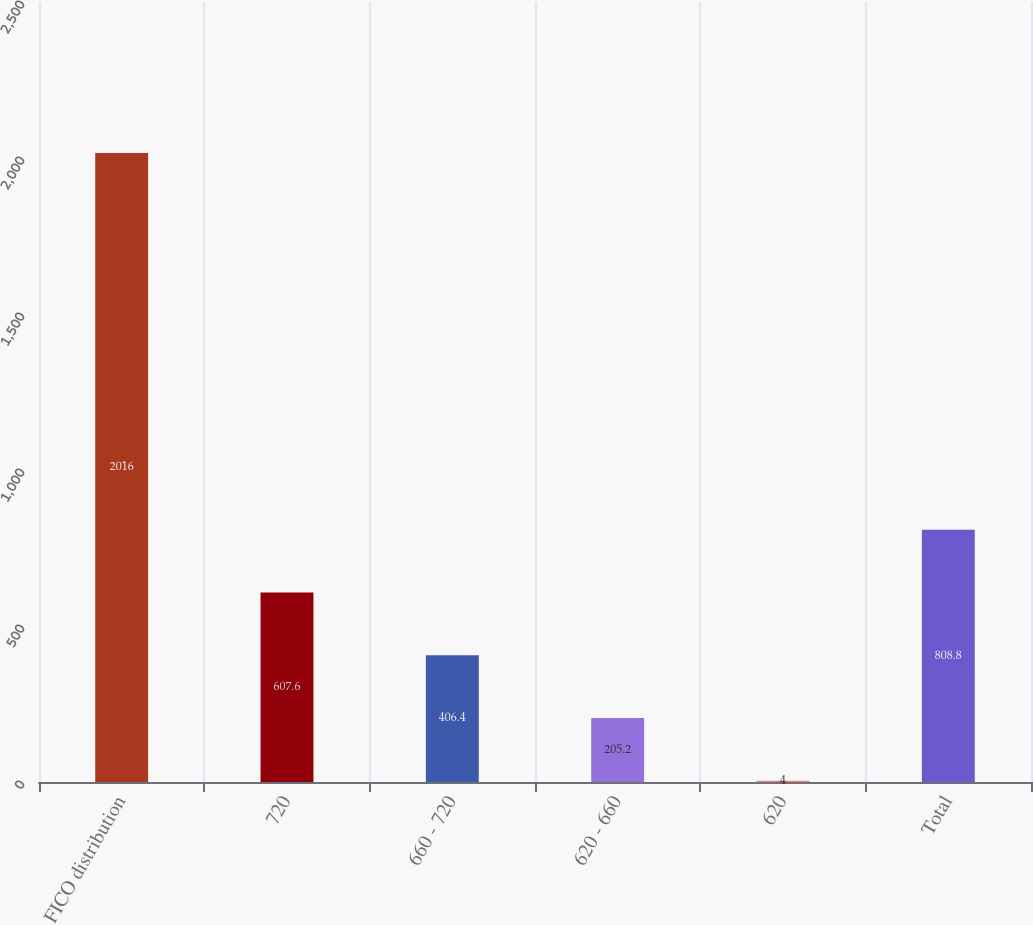Convert chart to OTSL. <chart><loc_0><loc_0><loc_500><loc_500><bar_chart><fcel>FICO distribution<fcel>720<fcel>660 - 720<fcel>620 - 660<fcel>620<fcel>Total<nl><fcel>2016<fcel>607.6<fcel>406.4<fcel>205.2<fcel>4<fcel>808.8<nl></chart> 